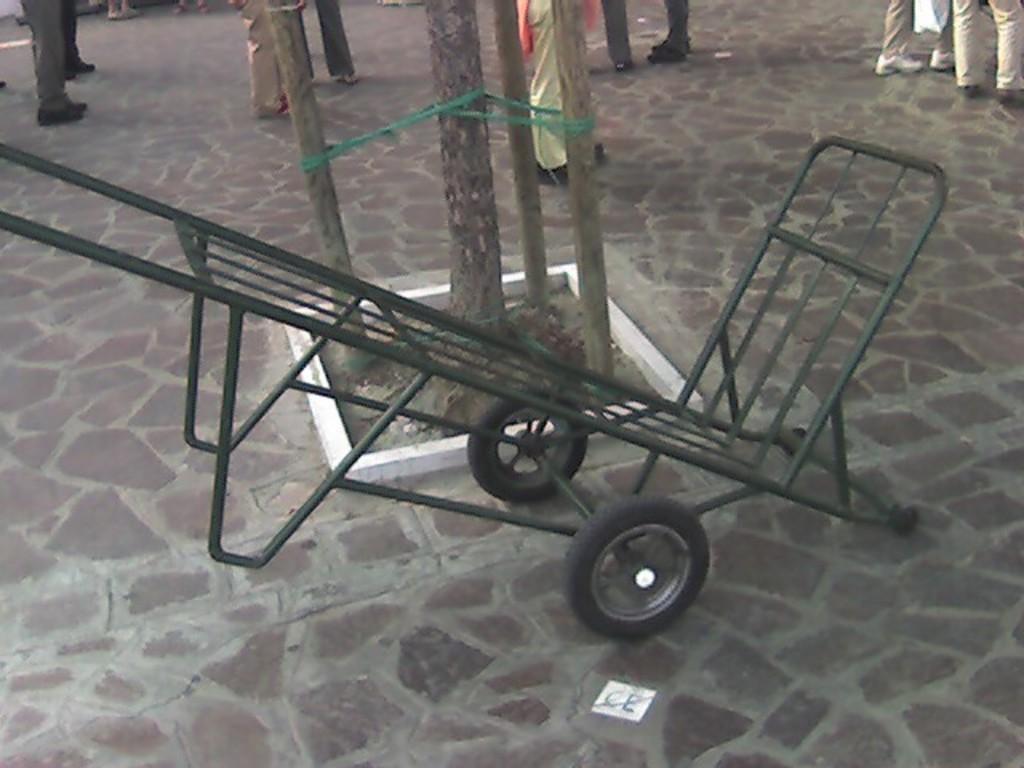Describe this image in one or two sentences. In this picture we can see a trolley on the path. There are tree trunks on the path. Few people are visible in the background. 